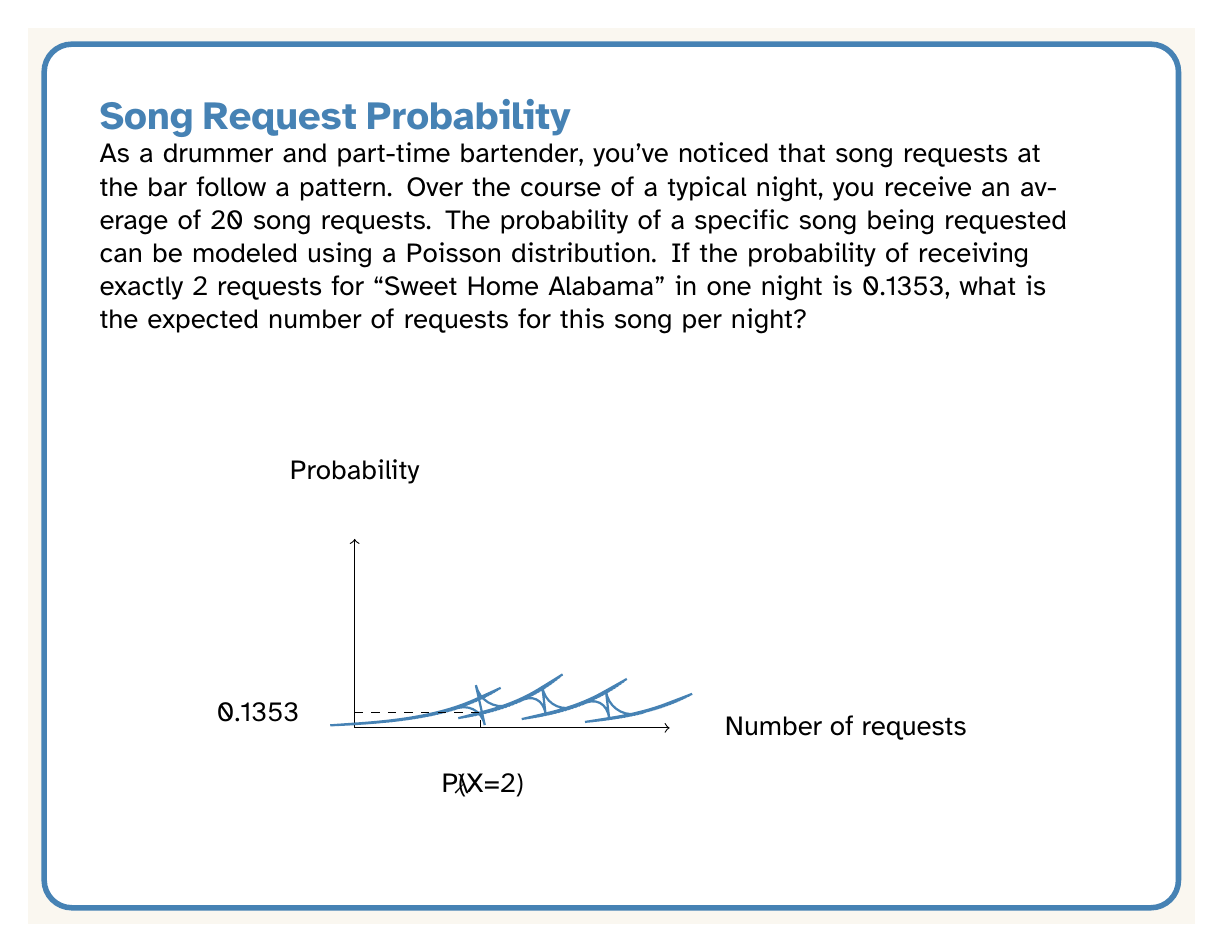Could you help me with this problem? Let's approach this step-by-step:

1) The Poisson distribution is given by the formula:

   $$P(X = k) = \frac{e^{-\lambda}\lambda^k}{k!}$$

   where $\lambda$ is the expected number of occurrences and $k$ is the number of occurrences we're interested in.

2) We're told that $P(X = 2) = 0.1353$ and we need to find $\lambda$. Let's substitute these into the formula:

   $$0.1353 = \frac{e^{-\lambda}\lambda^2}{2!}$$

3) Simplify:
   
   $$0.1353 = \frac{e^{-\lambda}\lambda^2}{2}$$

4) Multiply both sides by 2:

   $$0.2706 = e^{-\lambda}\lambda^2$$

5) Take the natural log of both sides:

   $$\ln(0.2706) = \ln(e^{-\lambda}\lambda^2)$$
   $$\ln(0.2706) = -\lambda + 2\ln(\lambda)$$

6) This equation can be solved numerically. Using a calculator or computer algebra system, we find:

   $$\lambda \approx 2$$

Therefore, the expected number of requests for "Sweet Home Alabama" per night is approximately 2.
Answer: $\lambda \approx 2$ requests per night 